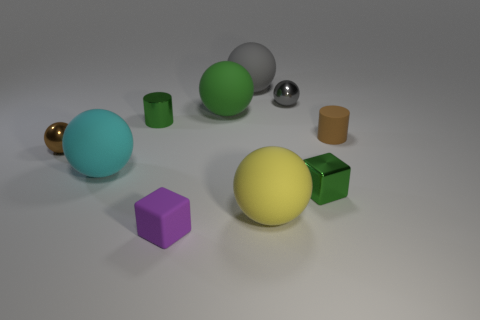Subtract all brown balls. How many balls are left? 5 Subtract all big gray rubber balls. How many balls are left? 5 Subtract all purple spheres. Subtract all brown cylinders. How many spheres are left? 6 Subtract all spheres. How many objects are left? 4 Subtract 0 yellow cylinders. How many objects are left? 10 Subtract all tiny red matte objects. Subtract all small purple blocks. How many objects are left? 9 Add 6 large spheres. How many large spheres are left? 10 Add 5 small red cylinders. How many small red cylinders exist? 5 